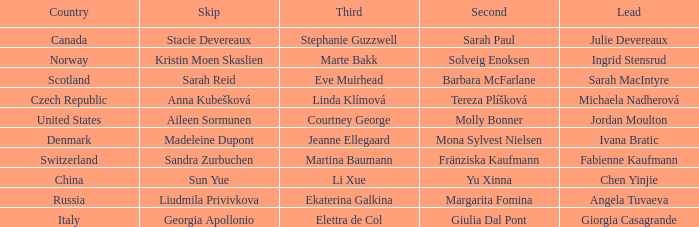What skip has martina baumann as the third? Sandra Zurbuchen. 